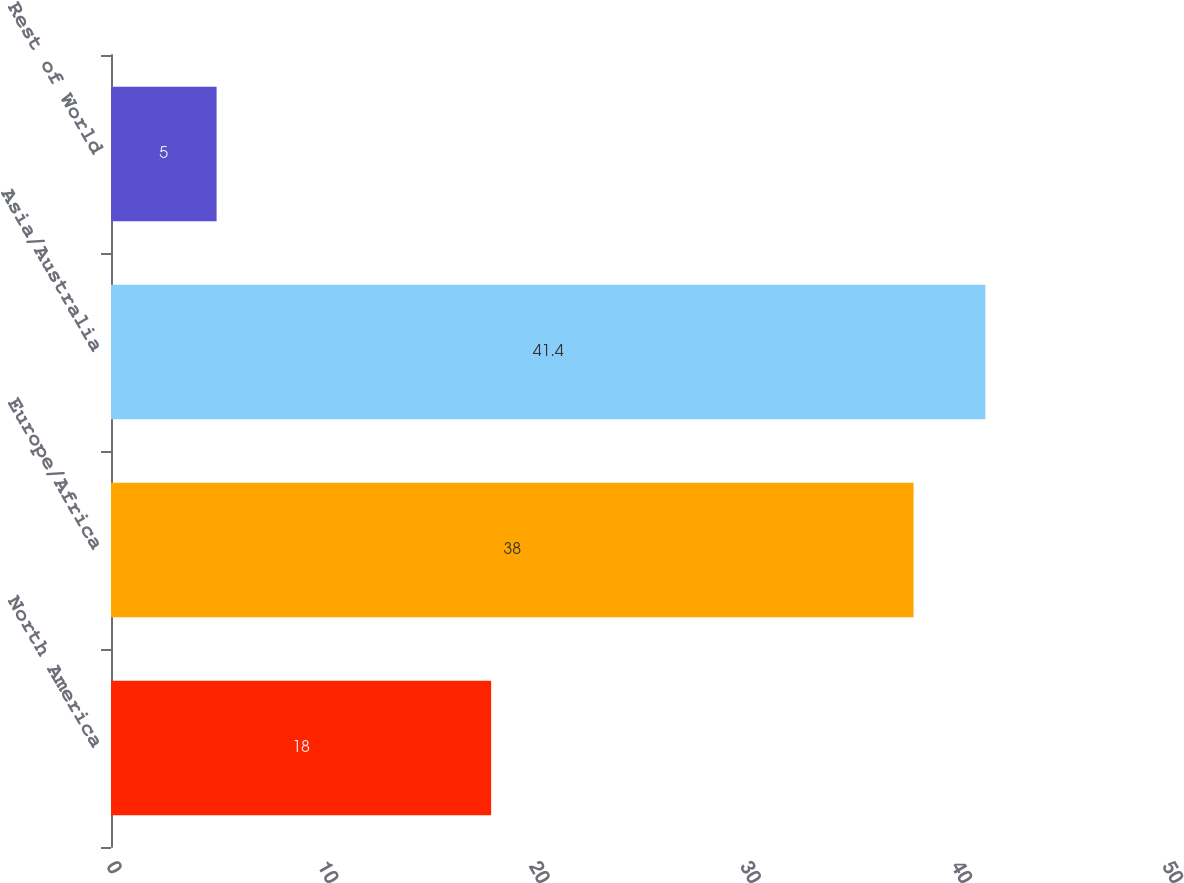Convert chart to OTSL. <chart><loc_0><loc_0><loc_500><loc_500><bar_chart><fcel>North America<fcel>Europe/Africa<fcel>Asia/Australia<fcel>Rest of World<nl><fcel>18<fcel>38<fcel>41.4<fcel>5<nl></chart> 